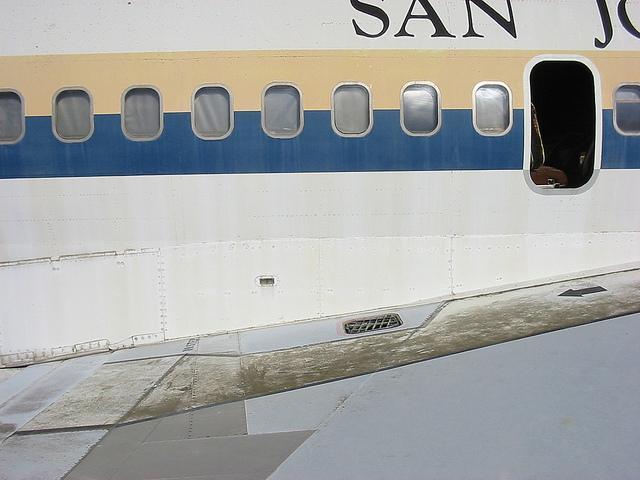How many boats are in the water?
Give a very brief answer. 0. 